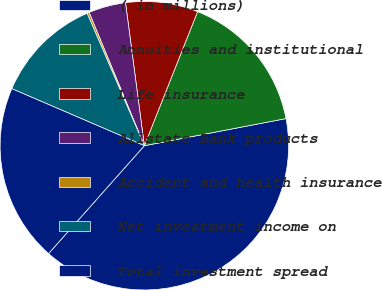<chart> <loc_0><loc_0><loc_500><loc_500><pie_chart><fcel>( in millions)<fcel>Annuities and institutional<fcel>Life insurance<fcel>Allstate Bank products<fcel>Accident and health insurance<fcel>Net investment income on<fcel>Total investment spread<nl><fcel>39.57%<fcel>15.97%<fcel>8.1%<fcel>4.17%<fcel>0.24%<fcel>12.04%<fcel>19.91%<nl></chart> 